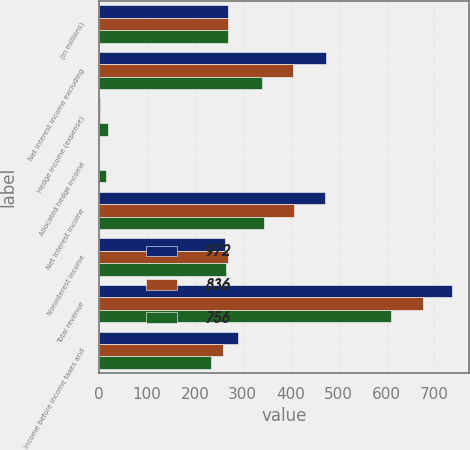<chart> <loc_0><loc_0><loc_500><loc_500><stacked_bar_chart><ecel><fcel>(In millions)<fcel>Net interest income excluding<fcel>Hedge income (expense)<fcel>Allocated hedge income<fcel>Net interest income<fcel>Noninterest income<fcel>Total revenue<fcel>Income before income taxes and<nl><fcel>972<fcel>269.2<fcel>473.9<fcel>2.2<fcel>0.6<fcel>472.3<fcel>263.7<fcel>736<fcel>290<nl><fcel>836<fcel>269.2<fcel>405.8<fcel>2.3<fcel>0.2<fcel>407.9<fcel>269.2<fcel>677.1<fcel>259.4<nl><fcel>756<fcel>269.2<fcel>340.5<fcel>18.7<fcel>15.4<fcel>343.8<fcel>265.9<fcel>609.7<fcel>234<nl></chart> 